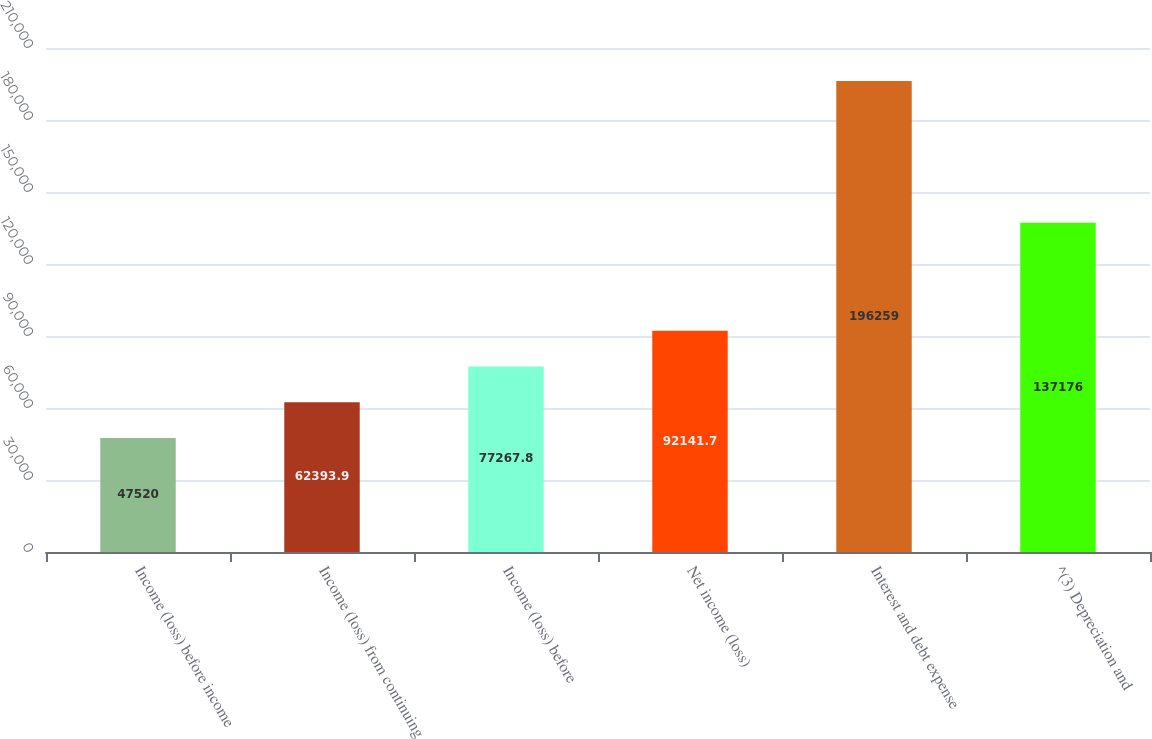Convert chart to OTSL. <chart><loc_0><loc_0><loc_500><loc_500><bar_chart><fcel>Income (loss) before income<fcel>Income (loss) from continuing<fcel>Income (loss) before<fcel>Net income (loss)<fcel>Interest and debt expense<fcel>^(3) Depreciation and<nl><fcel>47520<fcel>62393.9<fcel>77267.8<fcel>92141.7<fcel>196259<fcel>137176<nl></chart> 